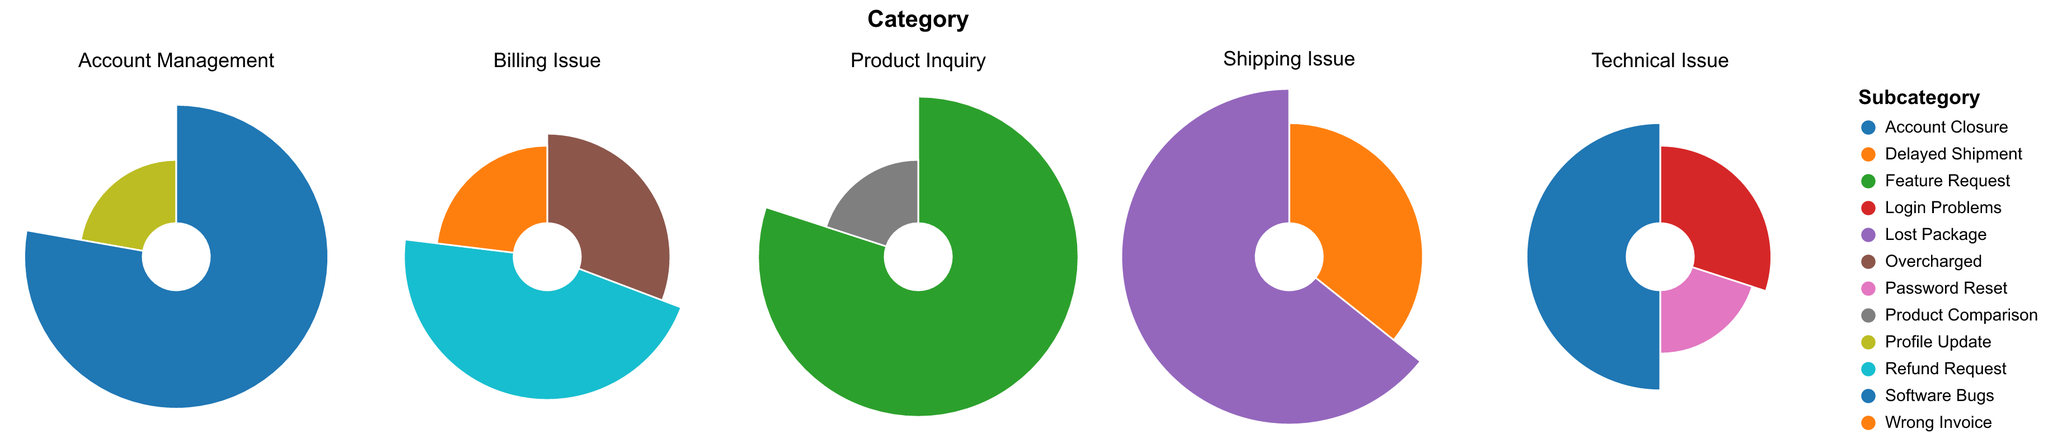Which subcategory in "Account Management" has the highest average resolution time? The subplot for "Account Management" shows two subcategories: "Profile Update" and "Account Closure". "Account Closure" has a noticeably larger slice. Comparing their values, "Account Closure" has an average resolution time of 7, which is higher than "Profile Update," which has an average of 2.
Answer: Account Closure Which category has subcategories with the shortest average resolution times? All categories consist of subcategories with various average resolution times. "Account Management" and "Technical Issue" contain subcategories with average resolution times as low as 2. Evaluating the lowest value in each, it is evident that "Account Management" (`Profile Update` with 2) and "Technical Issue" (`Password Reset` with 2) have the shortest times among their respective subcategories.
Answer: Account Management and Technical Issue What is the difference in the average resolution time between "Feature Request" and "Product Comparison" subcategories within "Product Inquiry"? Within the "Product Inquiry" subplot, "Feature Request" has an average resolution time of 8 and "Product Comparison" has 2. The difference is calculated as 8 - 2.
Answer: 6 Which issue has the longest average resolution time, and what is its value? Across all subplots, we observe that "Lost Package" under the "Shipping Issue" category takes the most extended period to resolve, with an average resolution time of 9.
Answer: Lost Package, 9 How does the average resolution time of "Refund Request" within "Billing Issue" compare to "Login Problems" within "Technical Issue"? "Refund Request" has an average resolution time of 6, while "Login Problems" has an average resolution time of 3. Comparing these times, "Refund Request" takes longer.
Answer: Refund Request takes longer What is the sum of the average resolution times for all subcategories under "Shipping Issue"? The "Shipping Issue" subplot shows two subcategories: "Delayed Shipment" with 5 and "Lost Package" with 9. Summing these values, 5 + 9, gives the total.
Answer: 14 Among the subcategories under "Billing Issue," which one has the lowest average resolution time, and what is this value? The "Billing Issue" category contains subcategories "Overcharged" (4), "Refund Request" (6), and "Wrong Invoice" (3). The subcategory with the lowest average resolution time is "Wrong Invoice" with a value of 3.
Answer: Wrong Invoice, 3 In the "Technical Issue" category, what is the average of the average resolution times of all subcategories? The "Technical Issue" subplot includes "Login Problems" (3), "Password Reset" (2), and "Software Bugs" (5). To find the average: (3 + 2 + 5) / 3.
Answer: 3.33 How do the average resolution times of "Technical Issue" subcategories collectively compare to those of "Shipping Issue" subcategories? Calculating the sum of average resolution times for "Technical Issue": 3 + 2 + 5 = 10. For "Shipping Issue": 5 + 9 = 14. Comparison shows that "Shipping Issue" subcategories have a higher collective average resolution time than "Technical Issue."
Answer: Shipping Issue subcategories have higher times 